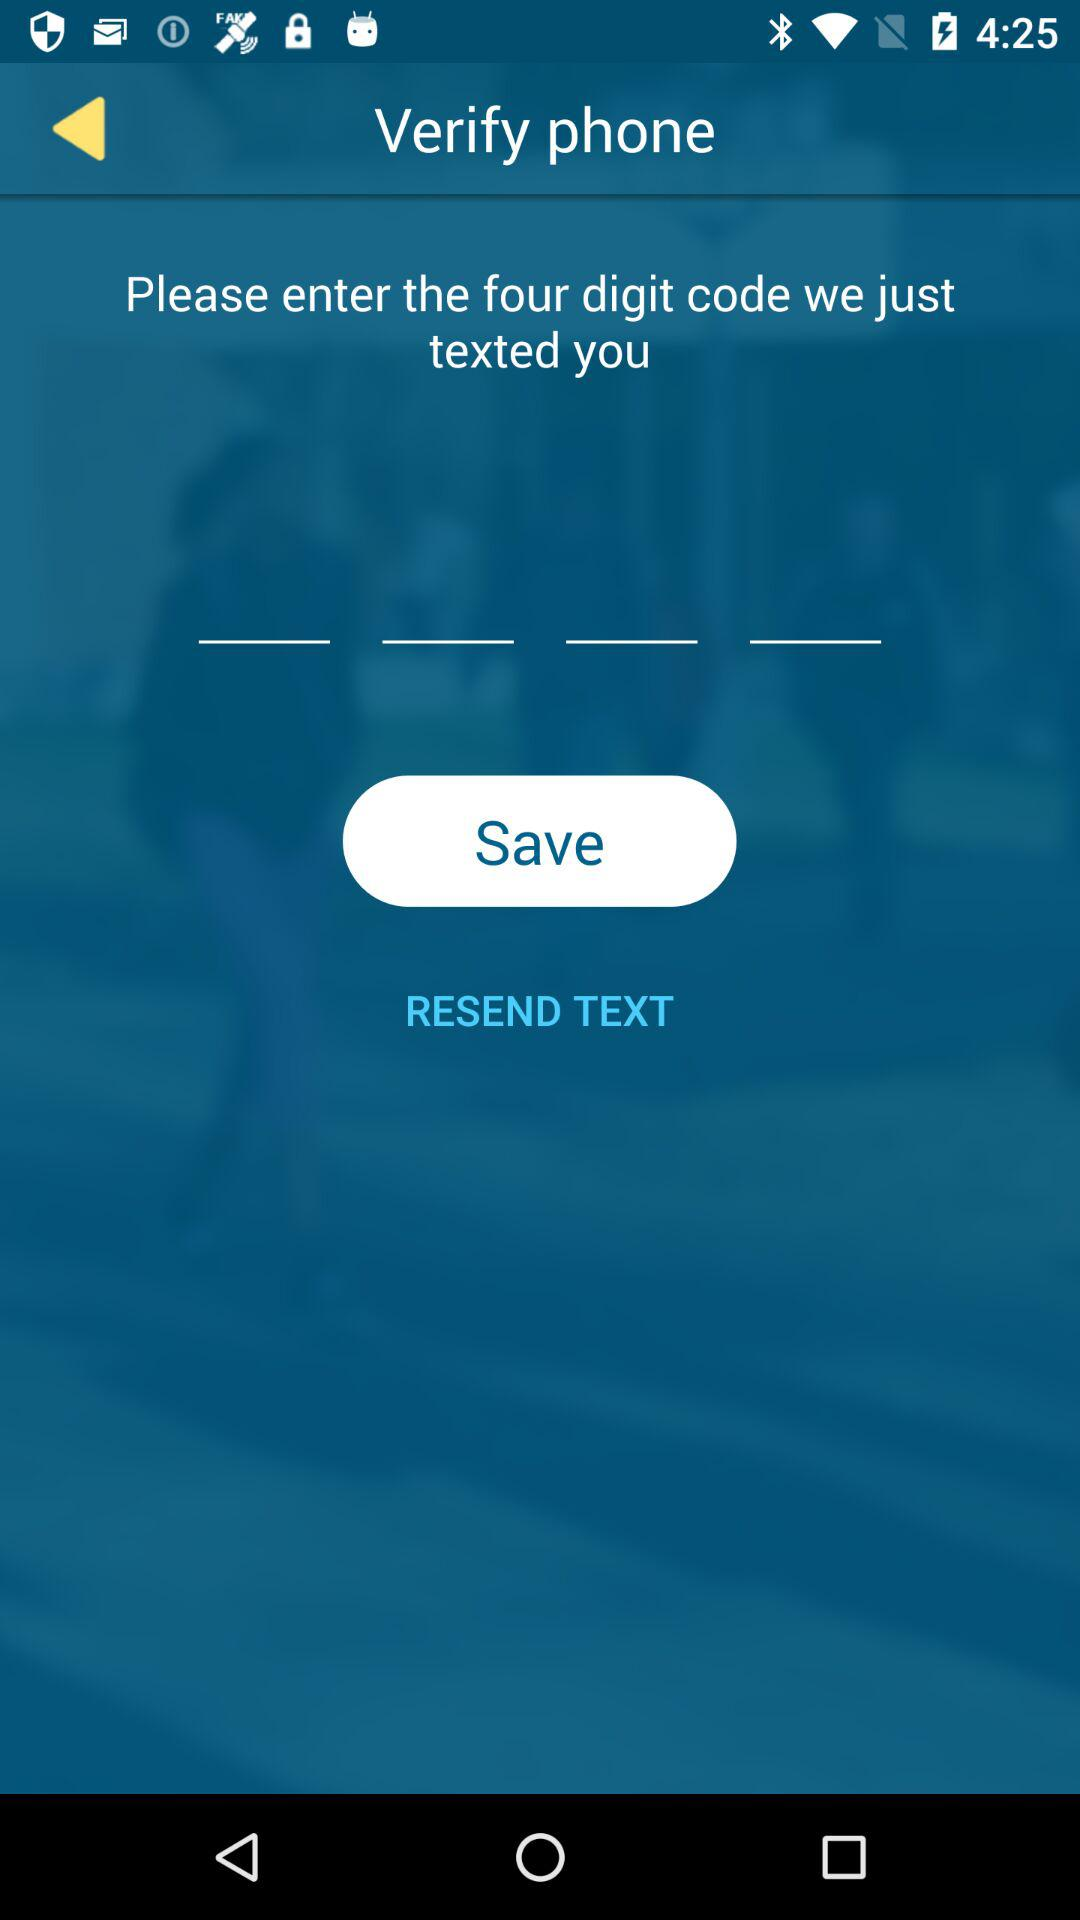How many text input fields are there in the verification screen?
Answer the question using a single word or phrase. 4 